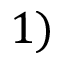<formula> <loc_0><loc_0><loc_500><loc_500>1 )</formula> 